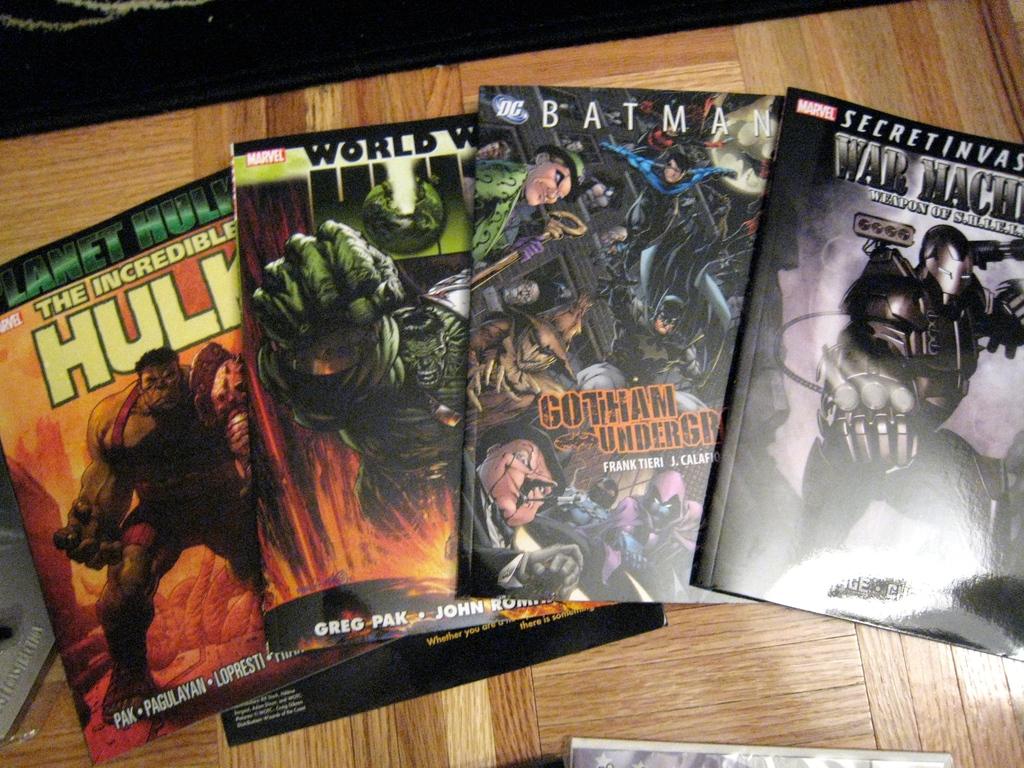What dark night is pictured on the gotham underground comic?
Give a very brief answer. Batman. What comic is on the left?
Provide a succinct answer. The incredible hulk. 